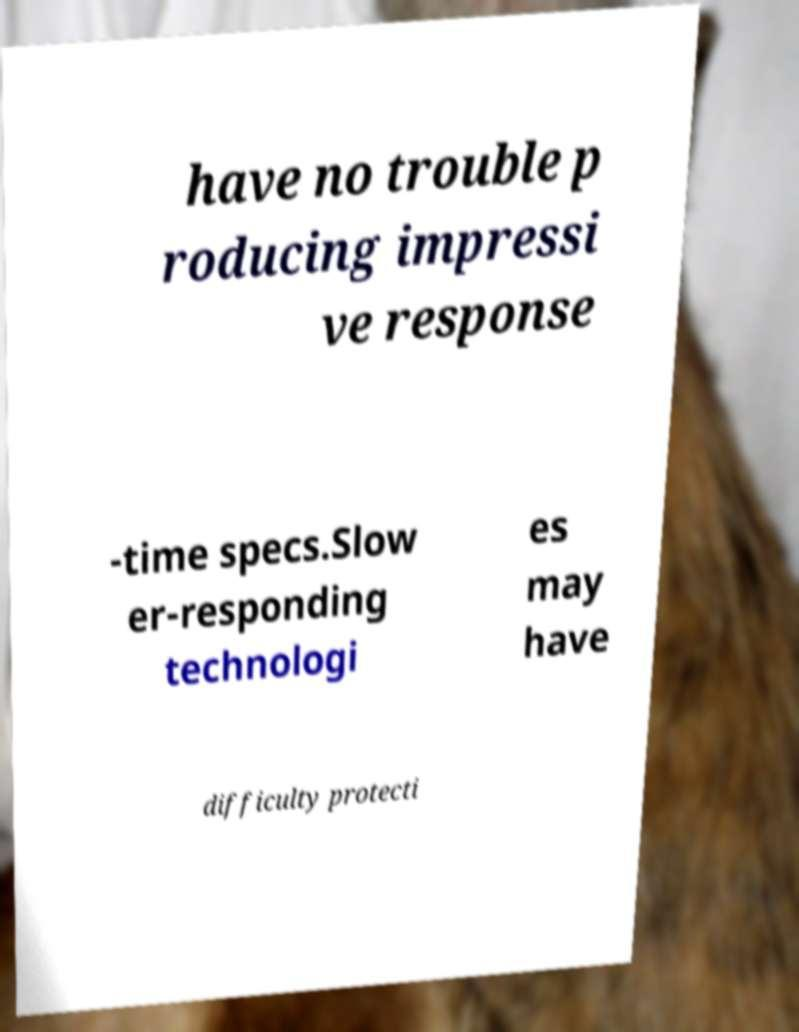What messages or text are displayed in this image? I need them in a readable, typed format. have no trouble p roducing impressi ve response -time specs.Slow er-responding technologi es may have difficulty protecti 